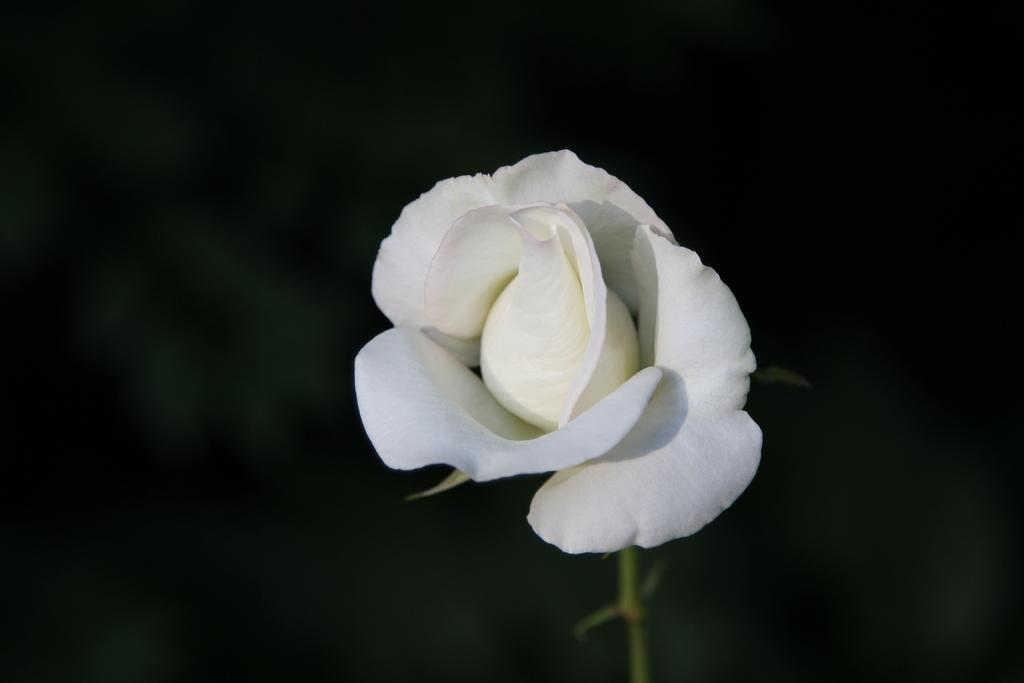What type of flower is present in the image? There is a white color flower in the image. How much of the flower's stem is visible in the image? The stem of the flower is truncated towards the bottom of the image. What is the color of the background in the image? The background of the image is dark. How many lizards can be seen crawling on the tongue in the image? There are no lizards or tongues present in the image; it features a white color flower with a truncated stem against a dark background. 